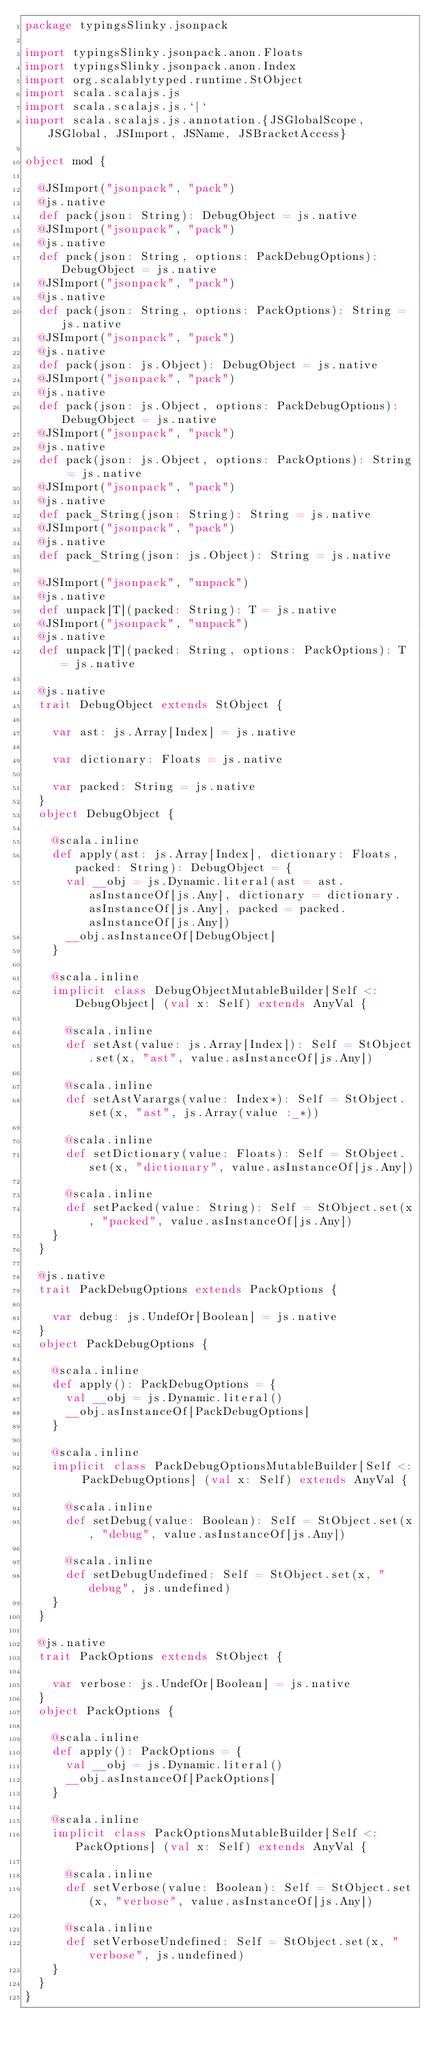Convert code to text. <code><loc_0><loc_0><loc_500><loc_500><_Scala_>package typingsSlinky.jsonpack

import typingsSlinky.jsonpack.anon.Floats
import typingsSlinky.jsonpack.anon.Index
import org.scalablytyped.runtime.StObject
import scala.scalajs.js
import scala.scalajs.js.`|`
import scala.scalajs.js.annotation.{JSGlobalScope, JSGlobal, JSImport, JSName, JSBracketAccess}

object mod {
  
  @JSImport("jsonpack", "pack")
  @js.native
  def pack(json: String): DebugObject = js.native
  @JSImport("jsonpack", "pack")
  @js.native
  def pack(json: String, options: PackDebugOptions): DebugObject = js.native
  @JSImport("jsonpack", "pack")
  @js.native
  def pack(json: String, options: PackOptions): String = js.native
  @JSImport("jsonpack", "pack")
  @js.native
  def pack(json: js.Object): DebugObject = js.native
  @JSImport("jsonpack", "pack")
  @js.native
  def pack(json: js.Object, options: PackDebugOptions): DebugObject = js.native
  @JSImport("jsonpack", "pack")
  @js.native
  def pack(json: js.Object, options: PackOptions): String = js.native
  @JSImport("jsonpack", "pack")
  @js.native
  def pack_String(json: String): String = js.native
  @JSImport("jsonpack", "pack")
  @js.native
  def pack_String(json: js.Object): String = js.native
  
  @JSImport("jsonpack", "unpack")
  @js.native
  def unpack[T](packed: String): T = js.native
  @JSImport("jsonpack", "unpack")
  @js.native
  def unpack[T](packed: String, options: PackOptions): T = js.native
  
  @js.native
  trait DebugObject extends StObject {
    
    var ast: js.Array[Index] = js.native
    
    var dictionary: Floats = js.native
    
    var packed: String = js.native
  }
  object DebugObject {
    
    @scala.inline
    def apply(ast: js.Array[Index], dictionary: Floats, packed: String): DebugObject = {
      val __obj = js.Dynamic.literal(ast = ast.asInstanceOf[js.Any], dictionary = dictionary.asInstanceOf[js.Any], packed = packed.asInstanceOf[js.Any])
      __obj.asInstanceOf[DebugObject]
    }
    
    @scala.inline
    implicit class DebugObjectMutableBuilder[Self <: DebugObject] (val x: Self) extends AnyVal {
      
      @scala.inline
      def setAst(value: js.Array[Index]): Self = StObject.set(x, "ast", value.asInstanceOf[js.Any])
      
      @scala.inline
      def setAstVarargs(value: Index*): Self = StObject.set(x, "ast", js.Array(value :_*))
      
      @scala.inline
      def setDictionary(value: Floats): Self = StObject.set(x, "dictionary", value.asInstanceOf[js.Any])
      
      @scala.inline
      def setPacked(value: String): Self = StObject.set(x, "packed", value.asInstanceOf[js.Any])
    }
  }
  
  @js.native
  trait PackDebugOptions extends PackOptions {
    
    var debug: js.UndefOr[Boolean] = js.native
  }
  object PackDebugOptions {
    
    @scala.inline
    def apply(): PackDebugOptions = {
      val __obj = js.Dynamic.literal()
      __obj.asInstanceOf[PackDebugOptions]
    }
    
    @scala.inline
    implicit class PackDebugOptionsMutableBuilder[Self <: PackDebugOptions] (val x: Self) extends AnyVal {
      
      @scala.inline
      def setDebug(value: Boolean): Self = StObject.set(x, "debug", value.asInstanceOf[js.Any])
      
      @scala.inline
      def setDebugUndefined: Self = StObject.set(x, "debug", js.undefined)
    }
  }
  
  @js.native
  trait PackOptions extends StObject {
    
    var verbose: js.UndefOr[Boolean] = js.native
  }
  object PackOptions {
    
    @scala.inline
    def apply(): PackOptions = {
      val __obj = js.Dynamic.literal()
      __obj.asInstanceOf[PackOptions]
    }
    
    @scala.inline
    implicit class PackOptionsMutableBuilder[Self <: PackOptions] (val x: Self) extends AnyVal {
      
      @scala.inline
      def setVerbose(value: Boolean): Self = StObject.set(x, "verbose", value.asInstanceOf[js.Any])
      
      @scala.inline
      def setVerboseUndefined: Self = StObject.set(x, "verbose", js.undefined)
    }
  }
}
</code> 